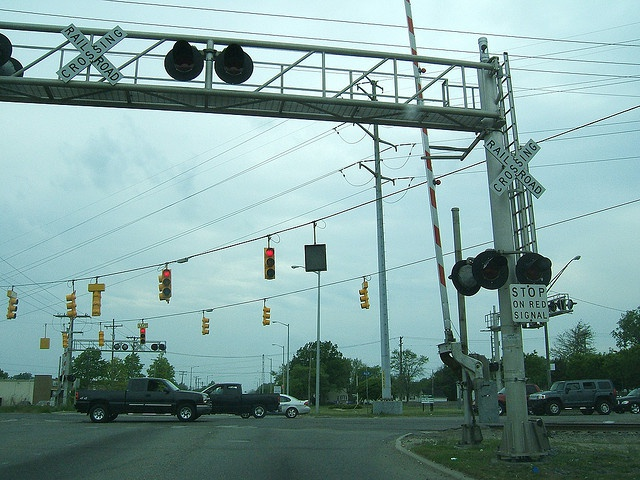Describe the objects in this image and their specific colors. I can see truck in lightblue, black, and teal tones, car in lightblue, black, teal, and darkgreen tones, truck in lightblue, black, teal, and darkblue tones, traffic light in lightblue, black, and teal tones, and truck in lightblue, black, teal, and darkgreen tones in this image. 